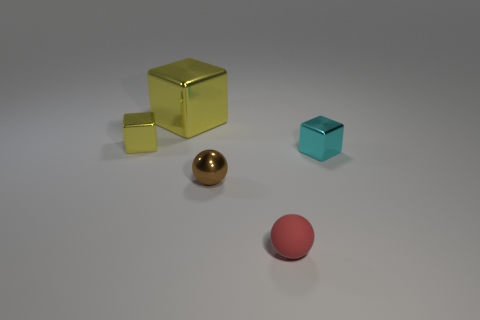Add 3 blue metallic balls. How many objects exist? 8 Subtract all brown spheres. Subtract all gray cubes. How many spheres are left? 1 Subtract all balls. How many objects are left? 3 Subtract all tiny matte balls. Subtract all cyan cubes. How many objects are left? 3 Add 4 large metal objects. How many large metal objects are left? 5 Add 4 small objects. How many small objects exist? 8 Subtract 0 cyan balls. How many objects are left? 5 